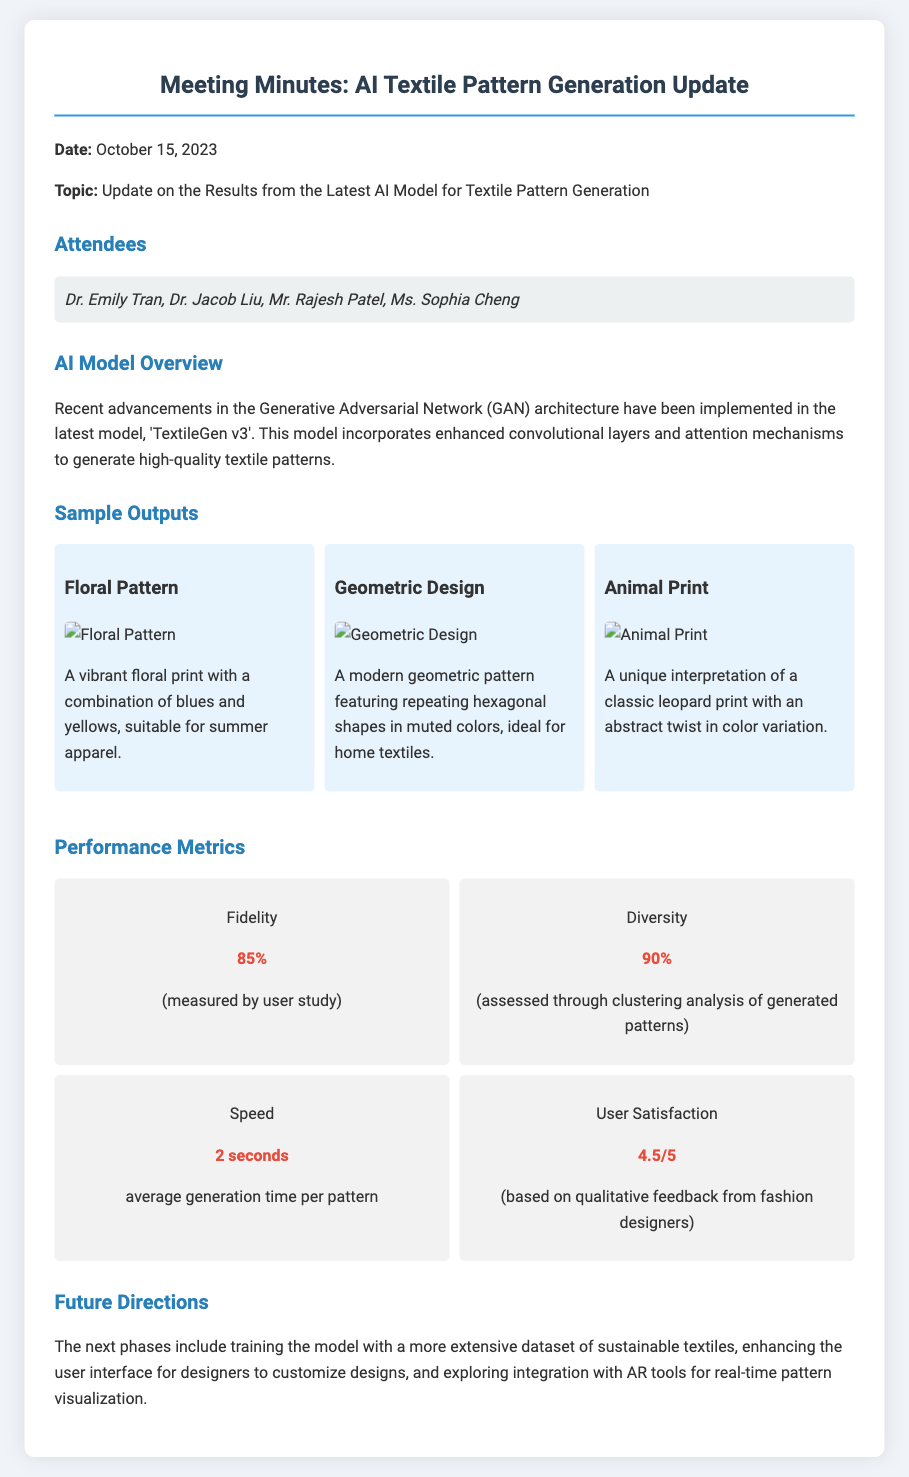What is the date of the meeting? The date of the meeting is mentioned at the beginning of the document.
Answer: October 15, 2023 Who is one of the attendees? The attendees list includes Dr. Emily Tran, among others.
Answer: Dr. Emily Tran What is the name of the AI model discussed? The model discussed in the meeting is named 'TextileGen v3'.
Answer: TextileGen v3 What is the fidelity metric? The fidelity metric is presented in the performance metrics section of the document.
Answer: 85% What is the average generation time per pattern? The average generation time is noted in the performance metrics, providing insight into the model's speed.
Answer: 2 seconds What type of pattern is described as a "vibrant floral print"? This description refers to a specific sample output demonstrated in the document.
Answer: Floral Pattern How satisfied were users according to the user satisfaction metric? User satisfaction is measured in the performance metrics and is rated on a scale.
Answer: 4.5/5 What will the future phases include? The future directions specify the upcoming phases for the AI model.
Answer: Extensive dataset of sustainable textiles 